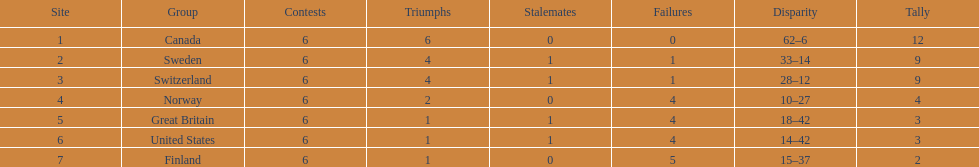Which team won more matches, finland or norway? Norway. 